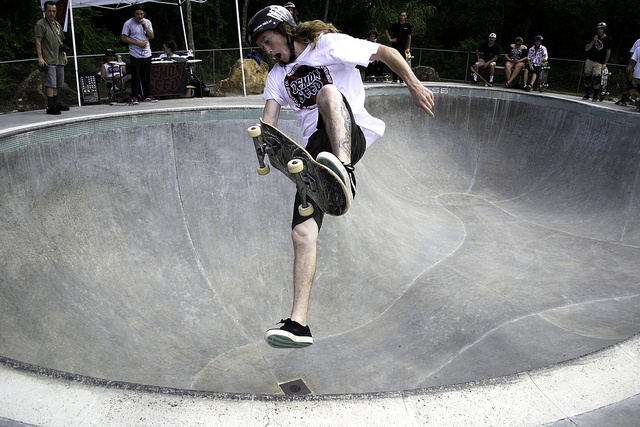Describe the objects in this image and their specific colors. I can see people in black, lavender, gray, and darkgray tones, skateboard in black, gray, darkgray, and ivory tones, people in black and gray tones, people in black and gray tones, and people in black and gray tones in this image. 